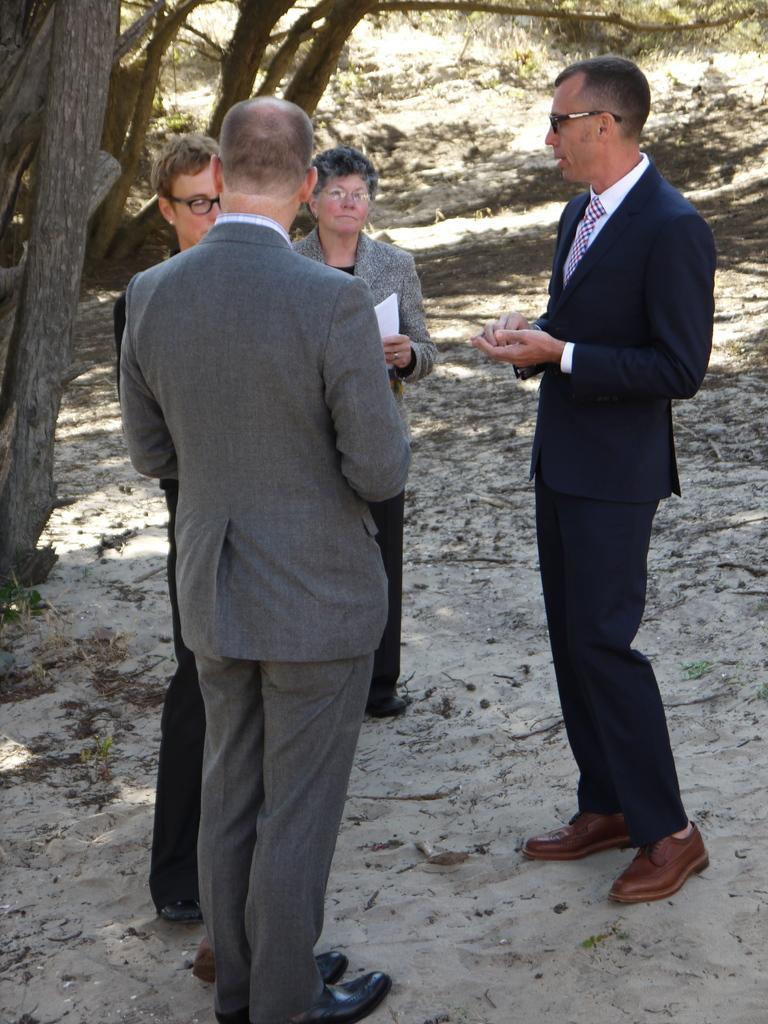Can you describe this image briefly? In the image we can see there are people standing, wearing clothes, shoes and some of them are wearing spectacles. Here we can see sad, dry leaves and tree branches. 